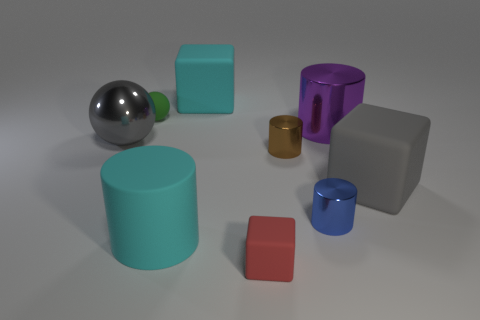Subtract all balls. How many objects are left? 7 Subtract 0 blue balls. How many objects are left? 9 Subtract all green matte balls. Subtract all small blue things. How many objects are left? 7 Add 8 large metallic cylinders. How many large metallic cylinders are left? 9 Add 8 tiny cyan metallic objects. How many tiny cyan metallic objects exist? 8 